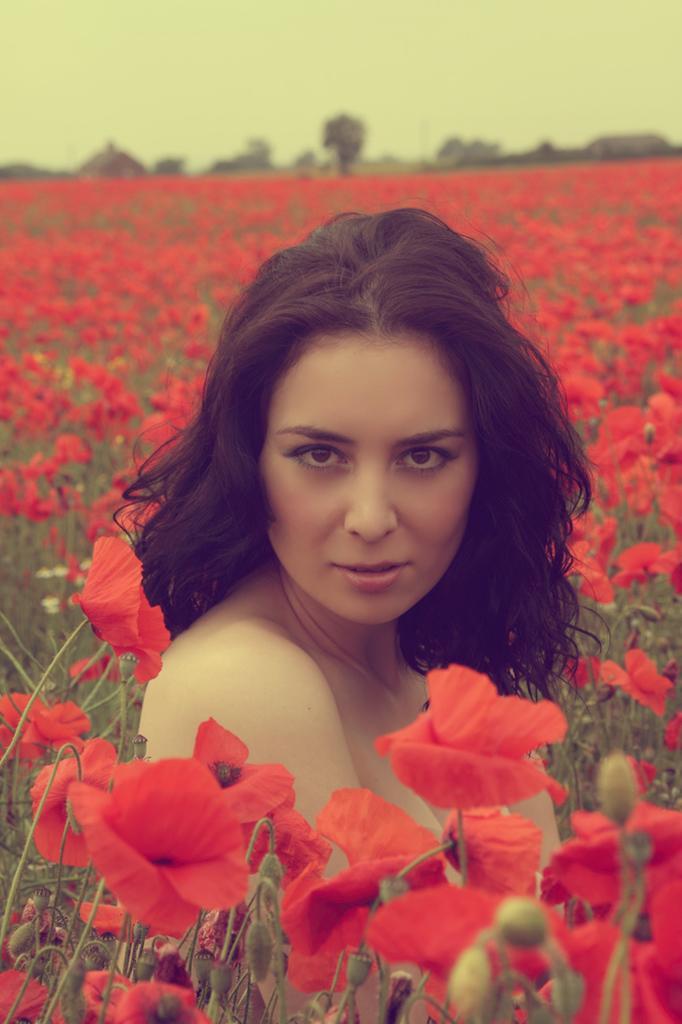Please provide a concise description of this image. In the picture we can see a woman around here we can see plants with flowers which are red in color and in the background we can see some trees and sky. 